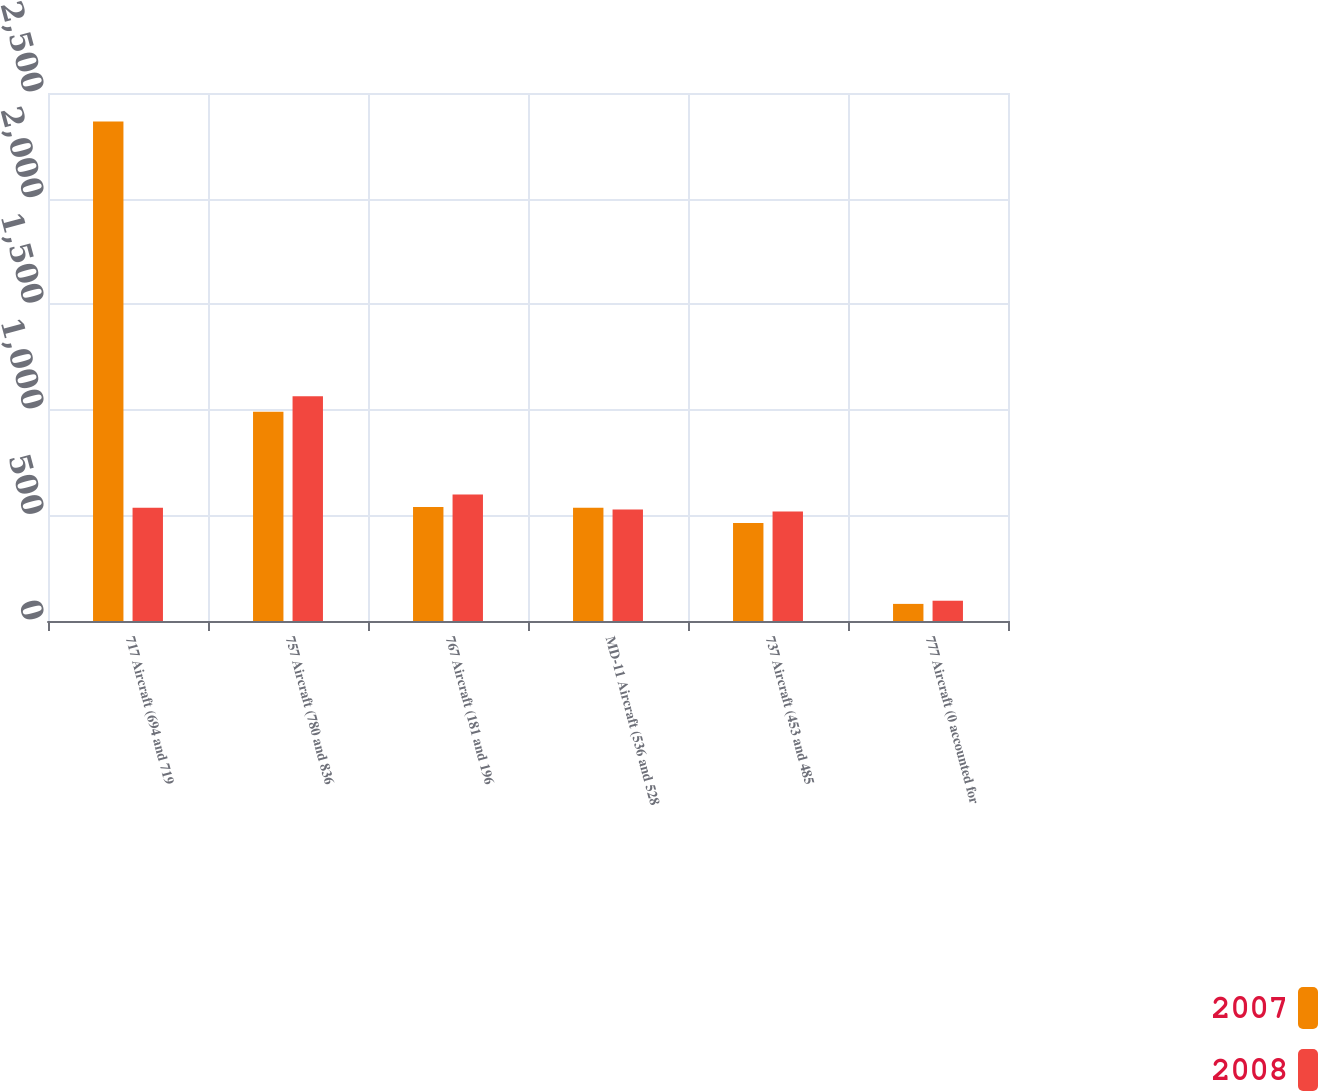Convert chart to OTSL. <chart><loc_0><loc_0><loc_500><loc_500><stacked_bar_chart><ecel><fcel>717 Aircraft (694 and 719<fcel>757 Aircraft (780 and 836<fcel>767 Aircraft (181 and 196<fcel>MD-11 Aircraft (536 and 528<fcel>737 Aircraft (453 and 485<fcel>777 Aircraft (0 accounted for<nl><fcel>2007<fcel>2365<fcel>991<fcel>540<fcel>536<fcel>464<fcel>81<nl><fcel>2008<fcel>536<fcel>1064<fcel>599<fcel>528<fcel>518<fcel>96<nl></chart> 